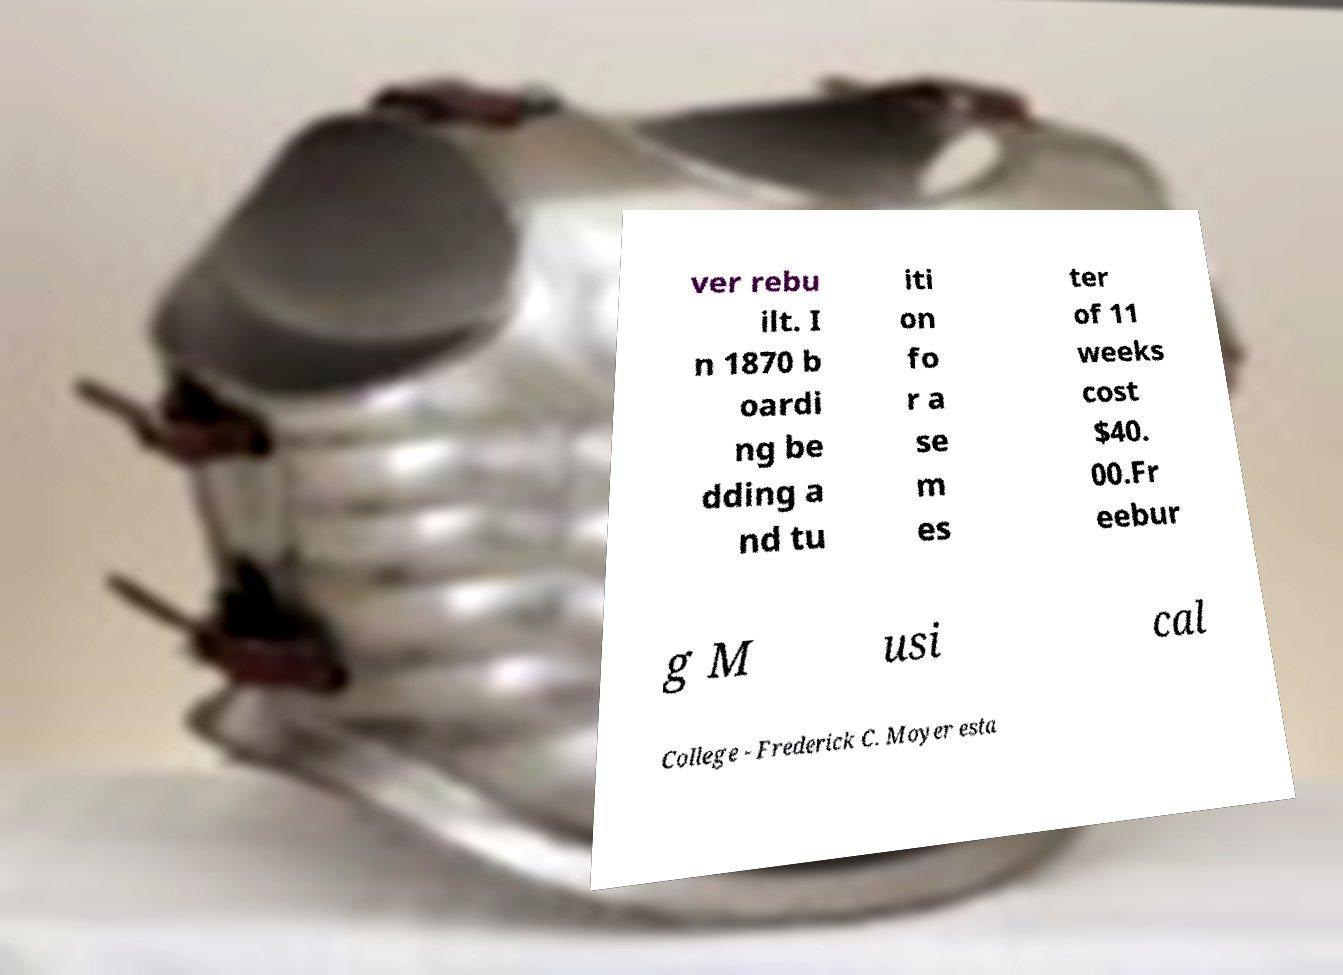For documentation purposes, I need the text within this image transcribed. Could you provide that? ver rebu ilt. I n 1870 b oardi ng be dding a nd tu iti on fo r a se m es ter of 11 weeks cost $40. 00.Fr eebur g M usi cal College - Frederick C. Moyer esta 